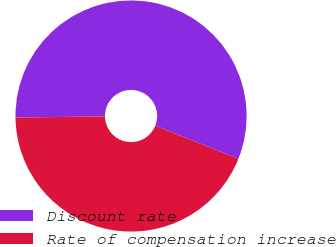Convert chart. <chart><loc_0><loc_0><loc_500><loc_500><pie_chart><fcel>Discount rate<fcel>Rate of compensation increase<nl><fcel>56.25%<fcel>43.75%<nl></chart> 